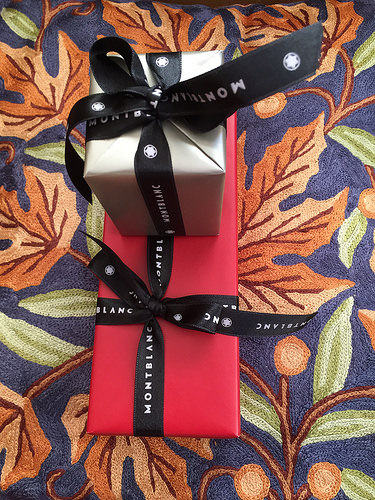<image>
Is there a gift on the gift? Yes. Looking at the image, I can see the gift is positioned on top of the gift, with the gift providing support. 